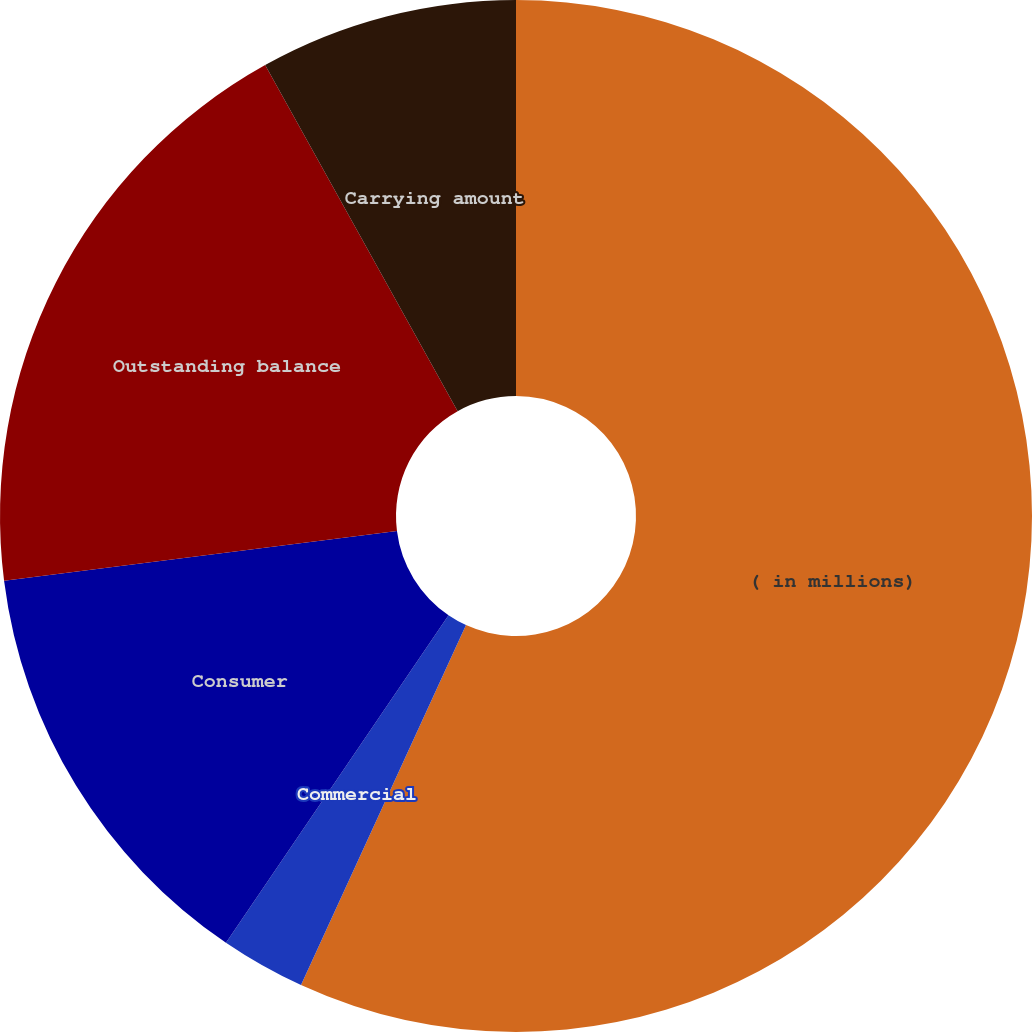<chart> <loc_0><loc_0><loc_500><loc_500><pie_chart><fcel>( in millions)<fcel>Commercial<fcel>Consumer<fcel>Outstanding balance<fcel>Carrying amount<nl><fcel>56.84%<fcel>2.66%<fcel>13.5%<fcel>18.92%<fcel>8.08%<nl></chart> 